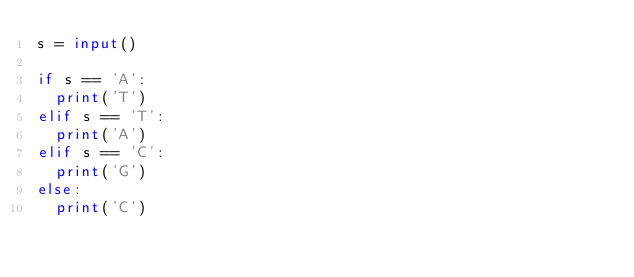<code> <loc_0><loc_0><loc_500><loc_500><_Python_>s = input()

if s == 'A':
  print('T')
elif s == 'T':
  print('A')
elif s == 'C':
  print('G')
else:
  print('C')</code> 